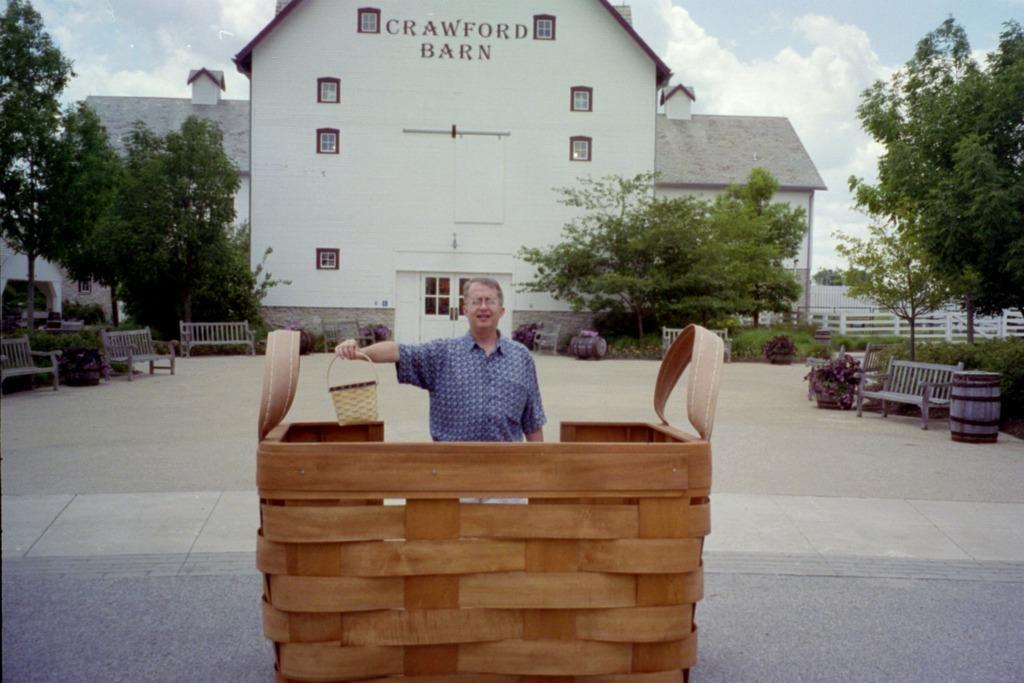How would you summarize this image in a sentence or two? In this image, at the middle there is a brown color wooden basket, there is a man standing and he is holding a small basket, there is a floor and there are some benches, there are some green color trees, at the top there is a sky. 